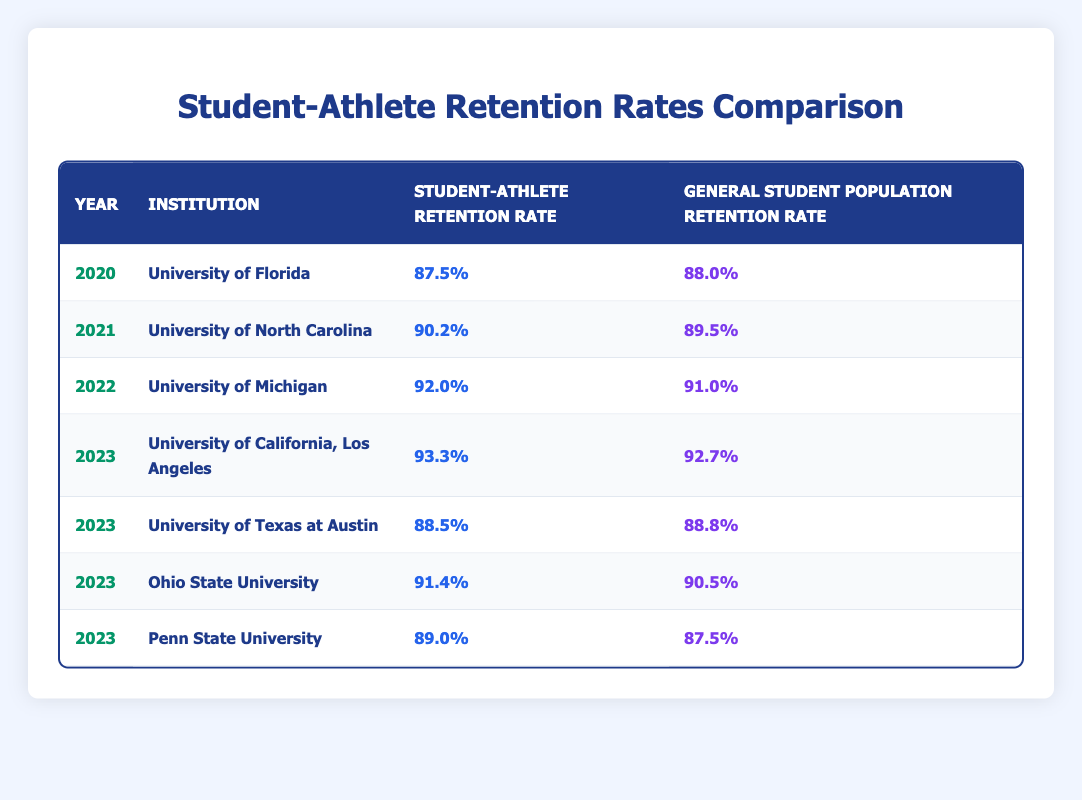What is the student-athlete retention rate for the University of Michigan in 2022? The table indicates that in 2022, the retention rate for student-athletes at the University of Michigan is listed as 92.0%.
Answer: 92.0% Which institution had the highest student-athlete retention rate in 2023? Referring to the 2023 data in the table, the University of California, Los Angeles has the highest student-athlete retention rate at 93.3%.
Answer: University of California, Los Angeles What was the general student population retention rate at Ohio State University in 2023? The table shows that the general student population retention rate at Ohio State University in 2023 is 90.5%.
Answer: 90.5% Which year did Penn State University have a lower student-athlete retention rate compared to the general student population? The table reveals that in 2023, Penn State University's student-athlete retention rate is 89.0%, which is higher than the general student population retention rate of 87.5%. The reverse is true in previous years as there's no instance noted in the table.
Answer: No What is the difference between the student-athlete retention rate and the general student population retention rate at the University of Texas at Austin in 2023? The student-athlete retention rate for the University of Texas at Austin is 88.5%, and the general rate is 88.8%. The difference is calculated as 88.8% - 88.5% = 0.3%.
Answer: 0.3% Calculate the average retention rate for student-athletes across all listed institutions in 2023. The student-athlete retention rates in 2023 are: 93.3%, 88.5%, 91.4%, and 89.0%. Adding these values gives 93.3 + 88.5 + 91.4 + 89.0 = 362.2%. There are 4 institutions, so the average is 362.2 / 4 = 90.55%.
Answer: 90.55% Is it true that the general student population retention rate was higher than the student-athlete retention rate at the University of Florida in 2020? The table shows a student-athlete retention rate of 87.5% and a general population rate of 88.0% for the University of Florida in 2020, indicating that the general rate was indeed higher.
Answer: Yes What trend can you identify about student-athlete retention rates from 2020 to 2023? The table displays a general increase in student-athlete retention rates from 87.5% in 2020 to 93.3% in 2023 for the University of California, Los Angeles. Other institutions also show varied levels of improvement or consistency, suggesting an overall upward trend.
Answer: Increasing trend Which institution had the smallest gap between student-athlete retention rates and general student population retention rates in 2023? By examining the 2023 data, the University of Texas at Austin has a gap of only 0.3% (88.8% - 88.5%), which is the smallest among all listed universities.
Answer: University of Texas at Austin 